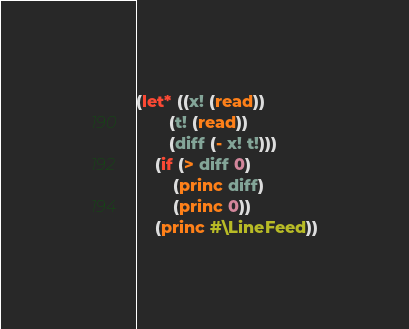<code> <loc_0><loc_0><loc_500><loc_500><_Lisp_>(let* ((x! (read))
       (t! (read))
       (diff (- x! t!)))
    (if (> diff 0)
        (princ diff)
        (princ 0))
    (princ #\LineFeed))</code> 